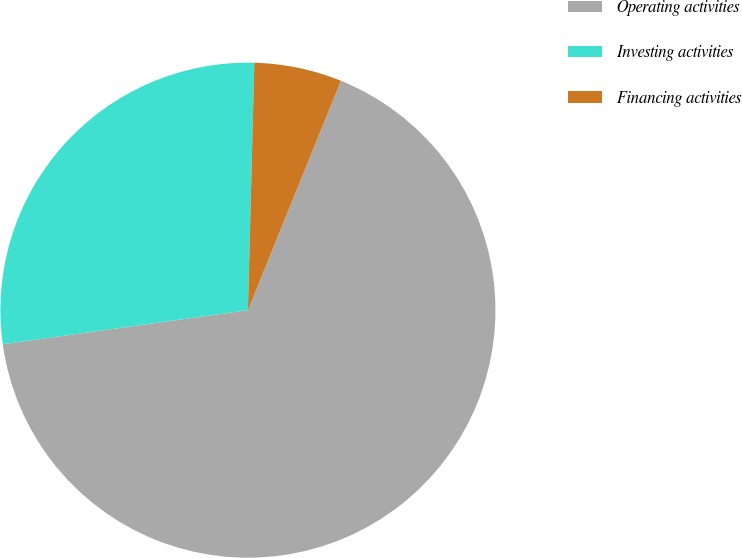<chart> <loc_0><loc_0><loc_500><loc_500><pie_chart><fcel>Operating activities<fcel>Investing activities<fcel>Financing activities<nl><fcel>66.67%<fcel>27.61%<fcel>5.72%<nl></chart> 